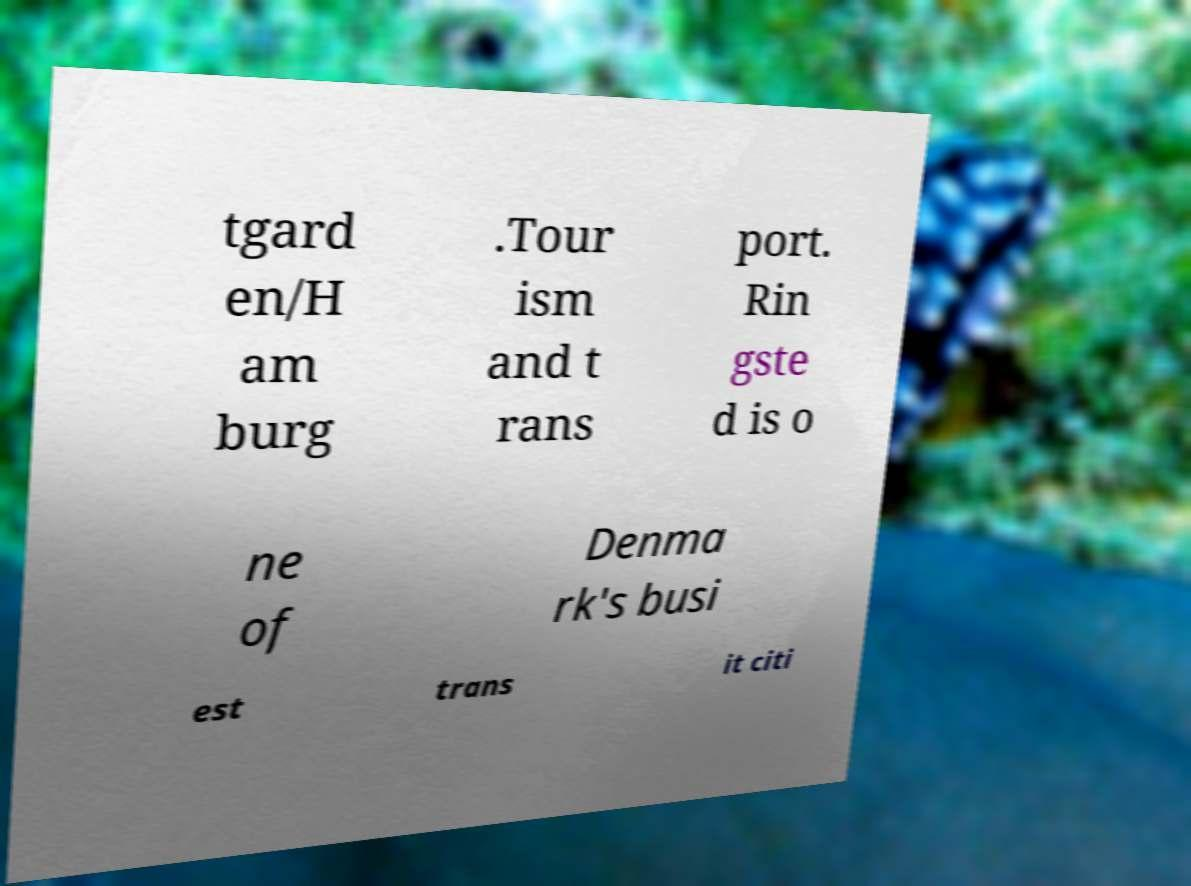Can you read and provide the text displayed in the image?This photo seems to have some interesting text. Can you extract and type it out for me? tgard en/H am burg .Tour ism and t rans port. Rin gste d is o ne of Denma rk's busi est trans it citi 